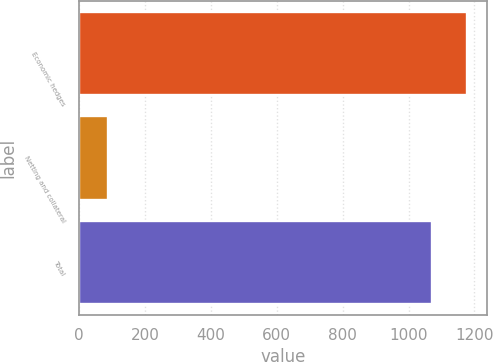<chart> <loc_0><loc_0><loc_500><loc_500><bar_chart><fcel>Economic hedges<fcel>Netting and collateral<fcel>Total<nl><fcel>1178.1<fcel>88<fcel>1071<nl></chart> 